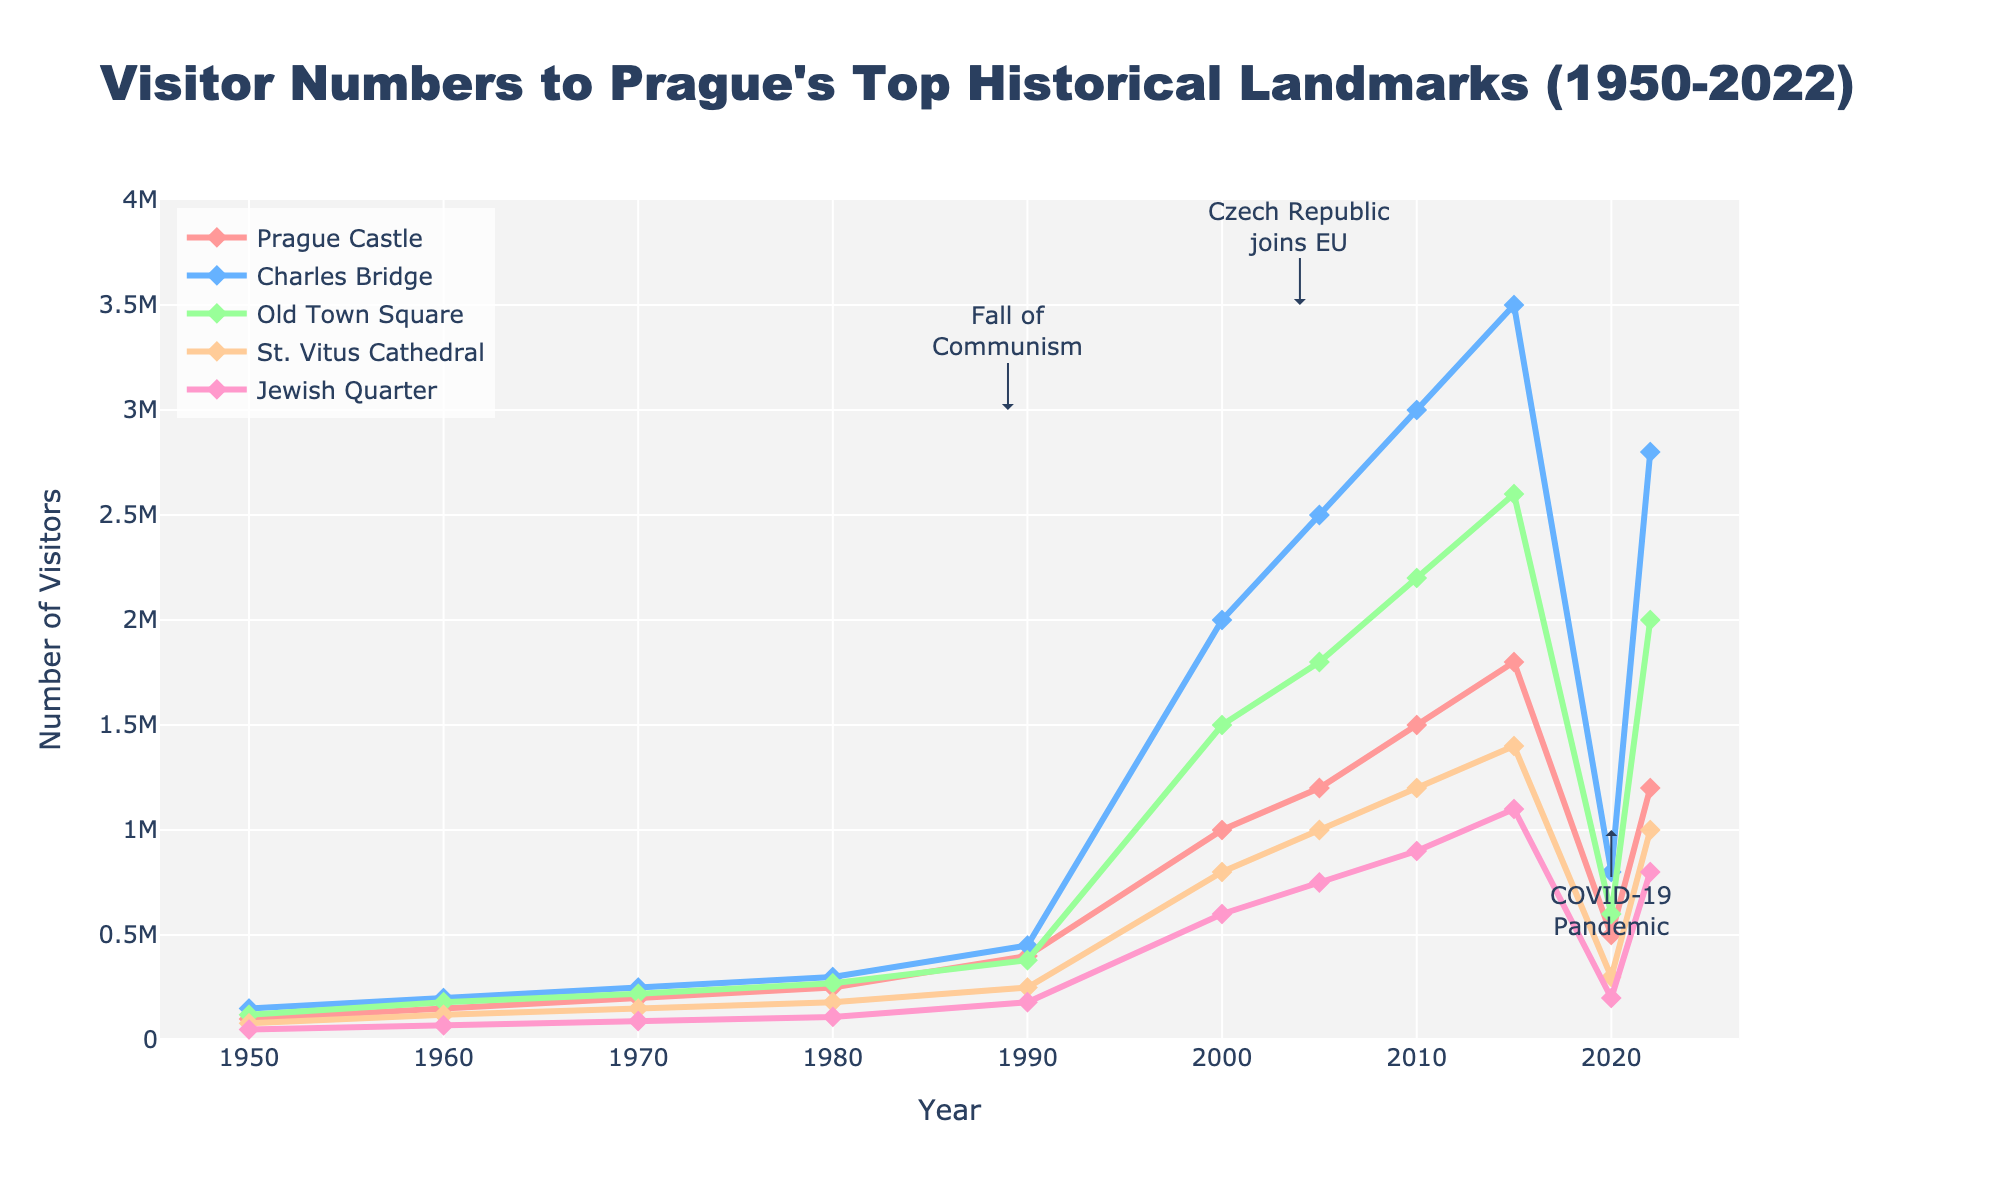What's the trend in visitor numbers to Prague Castle from 1950 to 2022? From the figure, the number of visitors to Prague Castle steadily increases from 100,000 in 1950 to 1,800,000 in 2015, drastically dropping to 500,000 in 2020, and then rising again to 1,200,000 in 2022.
Answer: Increasing till 2015, then decline in 2020, rebound in 2022 Which landmark had the highest number of visitors in 2010? Looking at the visitor numbers in 2010, Charles Bridge had the highest number of visitors with 3,000,000 followed by Old Town Square with 2,200,000.
Answer: Charles Bridge Compare the visitor numbers of St. Vitus Cathedral and Jewish Quarter in 1980. Which one had more visitors? According to the chart in 1980, St. Vitus Cathedral had 180,000 visitors while the Jewish Quarter had 110,000 visitors. St. Vitus Cathedral had more visitors.
Answer: St. Vitus Cathedral What was the effect of the COVID-19 pandemic on visitor numbers to Charles Bridge between 2015 and 2020? Visitor numbers at Charles Bridge were at 3,500,000 in 2015 and dropped significantly to 800,000 in 2020, indicating a substantial decline due to the pandemic.
Answer: Significant decline How did the visitor numbers to Old Town Square change from 2000 to 2022? Visitor numbers to Old Town Square rose from 1,500,000 in 2000 to 2,600,000 in 2015 but dropped to 600,000 in 2020, then increased to 2,000,000 in 2022.
Answer: Increase, then drop, then rise again What are the visitor trends for Jewish Quarter between 1950 and 2000? Numbers rose steadily from 50,000 in 1950 to 600,000 in 2000, indicating a consistent upward trend over the years.
Answer: Upward trend Calculate the difference in visitor numbers between Prague Castle and St. Vitus Cathedral in 2022. In 2022, Prague Castle had 1,200,000 visitors and St. Vitus Cathedral had 1,000,000 visitors. The difference in visitor numbers is 1,200,000 - 1,000,000 = 200,000.
Answer: 200,000 Examine which landmark had the smallest decline in visitor numbers between 2015 and 2020. Comparing all landmarks, St. Vitus Cathedral had the smallest decline from 1,400,000 in 2015 to 300,000 in 2020, a drop of 1,100,000. All other landmarks had larger declines.
Answer: St. Vitus Cathedral Between which years did Prague Castle experience the most rapid increase in visitors? The number of visitors to Prague Castle rose from 400,000 in 1990 to 1,000,000 in 2000, marking a 600,000 increase, which is the most rapid increase in visitors.
Answer: Between 1990 and 2000 What's the overall trend for visitor numbers to all landmarks from 1950 to 2022? Visitor numbers to all landmarks generally show an increasing trend over the period from 1950 to 2015, a sharp decline in 2020, and partial recovery by 2022.
Answer: Increasing till 2015, decline in 2020, partial recovery by 2022 